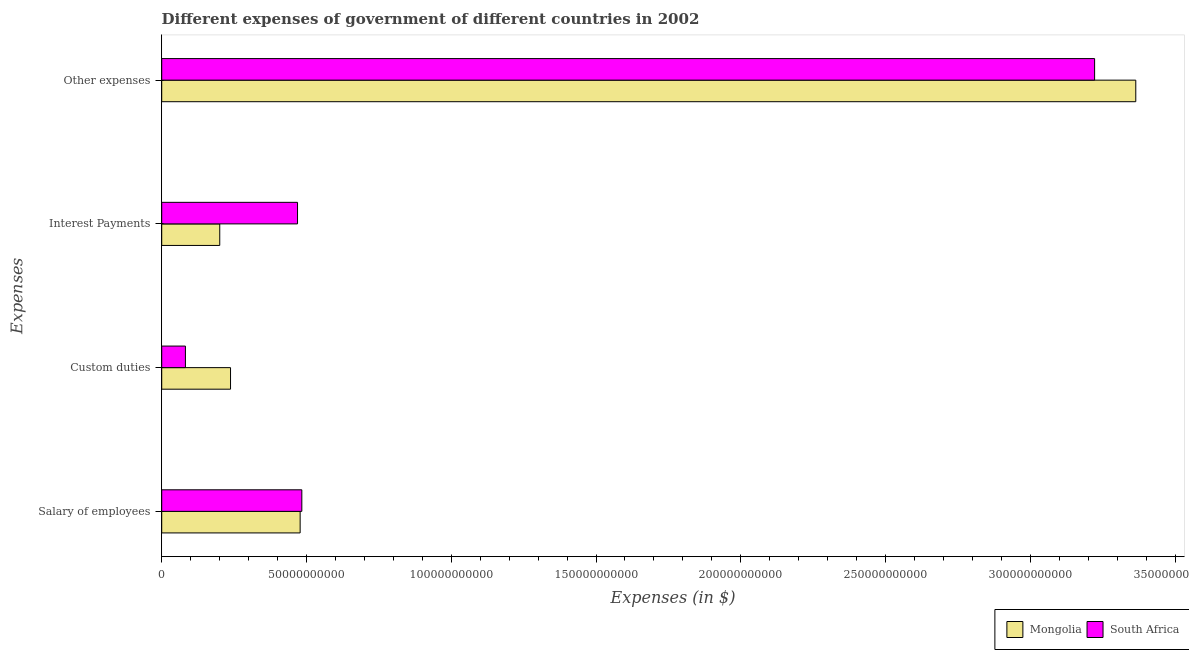How many groups of bars are there?
Give a very brief answer. 4. Are the number of bars on each tick of the Y-axis equal?
Make the answer very short. Yes. How many bars are there on the 4th tick from the top?
Your answer should be compact. 2. What is the label of the 2nd group of bars from the top?
Your answer should be very brief. Interest Payments. What is the amount spent on other expenses in South Africa?
Your answer should be very brief. 3.22e+11. Across all countries, what is the maximum amount spent on other expenses?
Your answer should be very brief. 3.36e+11. Across all countries, what is the minimum amount spent on interest payments?
Make the answer very short. 2.00e+1. In which country was the amount spent on custom duties maximum?
Make the answer very short. Mongolia. In which country was the amount spent on salary of employees minimum?
Your answer should be compact. Mongolia. What is the total amount spent on salary of employees in the graph?
Make the answer very short. 9.62e+1. What is the difference between the amount spent on interest payments in South Africa and that in Mongolia?
Keep it short and to the point. 2.69e+1. What is the difference between the amount spent on other expenses in Mongolia and the amount spent on interest payments in South Africa?
Your response must be concise. 2.90e+11. What is the average amount spent on other expenses per country?
Provide a short and direct response. 3.29e+11. What is the difference between the amount spent on other expenses and amount spent on salary of employees in South Africa?
Your answer should be compact. 2.74e+11. What is the ratio of the amount spent on interest payments in Mongolia to that in South Africa?
Give a very brief answer. 0.43. Is the difference between the amount spent on interest payments in South Africa and Mongolia greater than the difference between the amount spent on custom duties in South Africa and Mongolia?
Offer a terse response. Yes. What is the difference between the highest and the second highest amount spent on interest payments?
Give a very brief answer. 2.69e+1. What is the difference between the highest and the lowest amount spent on interest payments?
Your response must be concise. 2.69e+1. In how many countries, is the amount spent on salary of employees greater than the average amount spent on salary of employees taken over all countries?
Ensure brevity in your answer.  1. Is it the case that in every country, the sum of the amount spent on other expenses and amount spent on salary of employees is greater than the sum of amount spent on interest payments and amount spent on custom duties?
Give a very brief answer. Yes. What does the 1st bar from the top in Interest Payments represents?
Make the answer very short. South Africa. What does the 1st bar from the bottom in Other expenses represents?
Your response must be concise. Mongolia. How many countries are there in the graph?
Provide a succinct answer. 2. Does the graph contain any zero values?
Offer a very short reply. No. Does the graph contain grids?
Your answer should be compact. No. How many legend labels are there?
Make the answer very short. 2. How are the legend labels stacked?
Provide a succinct answer. Horizontal. What is the title of the graph?
Provide a short and direct response. Different expenses of government of different countries in 2002. Does "American Samoa" appear as one of the legend labels in the graph?
Provide a short and direct response. No. What is the label or title of the X-axis?
Provide a short and direct response. Expenses (in $). What is the label or title of the Y-axis?
Make the answer very short. Expenses. What is the Expenses (in $) of Mongolia in Salary of employees?
Provide a succinct answer. 4.78e+1. What is the Expenses (in $) of South Africa in Salary of employees?
Make the answer very short. 4.84e+1. What is the Expenses (in $) in Mongolia in Custom duties?
Offer a very short reply. 2.38e+1. What is the Expenses (in $) of South Africa in Custom duties?
Offer a very short reply. 8.19e+09. What is the Expenses (in $) in Mongolia in Interest Payments?
Your answer should be compact. 2.00e+1. What is the Expenses (in $) in South Africa in Interest Payments?
Keep it short and to the point. 4.69e+1. What is the Expenses (in $) of Mongolia in Other expenses?
Offer a very short reply. 3.36e+11. What is the Expenses (in $) of South Africa in Other expenses?
Your response must be concise. 3.22e+11. Across all Expenses, what is the maximum Expenses (in $) in Mongolia?
Give a very brief answer. 3.36e+11. Across all Expenses, what is the maximum Expenses (in $) in South Africa?
Make the answer very short. 3.22e+11. Across all Expenses, what is the minimum Expenses (in $) of Mongolia?
Offer a terse response. 2.00e+1. Across all Expenses, what is the minimum Expenses (in $) in South Africa?
Offer a terse response. 8.19e+09. What is the total Expenses (in $) of Mongolia in the graph?
Provide a short and direct response. 4.28e+11. What is the total Expenses (in $) of South Africa in the graph?
Provide a succinct answer. 4.26e+11. What is the difference between the Expenses (in $) of Mongolia in Salary of employees and that in Custom duties?
Offer a very short reply. 2.40e+1. What is the difference between the Expenses (in $) of South Africa in Salary of employees and that in Custom duties?
Make the answer very short. 4.02e+1. What is the difference between the Expenses (in $) in Mongolia in Salary of employees and that in Interest Payments?
Keep it short and to the point. 2.78e+1. What is the difference between the Expenses (in $) of South Africa in Salary of employees and that in Interest Payments?
Offer a very short reply. 1.49e+09. What is the difference between the Expenses (in $) of Mongolia in Salary of employees and that in Other expenses?
Keep it short and to the point. -2.89e+11. What is the difference between the Expenses (in $) in South Africa in Salary of employees and that in Other expenses?
Your response must be concise. -2.74e+11. What is the difference between the Expenses (in $) of Mongolia in Custom duties and that in Interest Payments?
Your answer should be compact. 3.72e+09. What is the difference between the Expenses (in $) in South Africa in Custom duties and that in Interest Payments?
Offer a very short reply. -3.87e+1. What is the difference between the Expenses (in $) in Mongolia in Custom duties and that in Other expenses?
Your answer should be compact. -3.13e+11. What is the difference between the Expenses (in $) of South Africa in Custom duties and that in Other expenses?
Your answer should be compact. -3.14e+11. What is the difference between the Expenses (in $) in Mongolia in Interest Payments and that in Other expenses?
Give a very brief answer. -3.16e+11. What is the difference between the Expenses (in $) in South Africa in Interest Payments and that in Other expenses?
Ensure brevity in your answer.  -2.75e+11. What is the difference between the Expenses (in $) in Mongolia in Salary of employees and the Expenses (in $) in South Africa in Custom duties?
Your answer should be compact. 3.96e+1. What is the difference between the Expenses (in $) of Mongolia in Salary of employees and the Expenses (in $) of South Africa in Interest Payments?
Your response must be concise. 9.05e+08. What is the difference between the Expenses (in $) of Mongolia in Salary of employees and the Expenses (in $) of South Africa in Other expenses?
Your answer should be compact. -2.74e+11. What is the difference between the Expenses (in $) of Mongolia in Custom duties and the Expenses (in $) of South Africa in Interest Payments?
Make the answer very short. -2.31e+1. What is the difference between the Expenses (in $) in Mongolia in Custom duties and the Expenses (in $) in South Africa in Other expenses?
Keep it short and to the point. -2.98e+11. What is the difference between the Expenses (in $) of Mongolia in Interest Payments and the Expenses (in $) of South Africa in Other expenses?
Your response must be concise. -3.02e+11. What is the average Expenses (in $) of Mongolia per Expenses?
Give a very brief answer. 1.07e+11. What is the average Expenses (in $) of South Africa per Expenses?
Provide a short and direct response. 1.06e+11. What is the difference between the Expenses (in $) of Mongolia and Expenses (in $) of South Africa in Salary of employees?
Give a very brief answer. -5.82e+08. What is the difference between the Expenses (in $) of Mongolia and Expenses (in $) of South Africa in Custom duties?
Make the answer very short. 1.56e+1. What is the difference between the Expenses (in $) in Mongolia and Expenses (in $) in South Africa in Interest Payments?
Ensure brevity in your answer.  -2.69e+1. What is the difference between the Expenses (in $) of Mongolia and Expenses (in $) of South Africa in Other expenses?
Provide a succinct answer. 1.42e+1. What is the ratio of the Expenses (in $) in Mongolia in Salary of employees to that in Custom duties?
Your answer should be very brief. 2.01. What is the ratio of the Expenses (in $) in South Africa in Salary of employees to that in Custom duties?
Your answer should be very brief. 5.91. What is the ratio of the Expenses (in $) of Mongolia in Salary of employees to that in Interest Payments?
Your answer should be compact. 2.39. What is the ratio of the Expenses (in $) in South Africa in Salary of employees to that in Interest Payments?
Your response must be concise. 1.03. What is the ratio of the Expenses (in $) in Mongolia in Salary of employees to that in Other expenses?
Keep it short and to the point. 0.14. What is the ratio of the Expenses (in $) of South Africa in Salary of employees to that in Other expenses?
Provide a short and direct response. 0.15. What is the ratio of the Expenses (in $) in Mongolia in Custom duties to that in Interest Payments?
Your response must be concise. 1.19. What is the ratio of the Expenses (in $) in South Africa in Custom duties to that in Interest Payments?
Ensure brevity in your answer.  0.17. What is the ratio of the Expenses (in $) in Mongolia in Custom duties to that in Other expenses?
Provide a short and direct response. 0.07. What is the ratio of the Expenses (in $) of South Africa in Custom duties to that in Other expenses?
Your answer should be very brief. 0.03. What is the ratio of the Expenses (in $) in Mongolia in Interest Payments to that in Other expenses?
Ensure brevity in your answer.  0.06. What is the ratio of the Expenses (in $) of South Africa in Interest Payments to that in Other expenses?
Your response must be concise. 0.15. What is the difference between the highest and the second highest Expenses (in $) of Mongolia?
Make the answer very short. 2.89e+11. What is the difference between the highest and the second highest Expenses (in $) in South Africa?
Give a very brief answer. 2.74e+11. What is the difference between the highest and the lowest Expenses (in $) of Mongolia?
Provide a short and direct response. 3.16e+11. What is the difference between the highest and the lowest Expenses (in $) in South Africa?
Your answer should be very brief. 3.14e+11. 